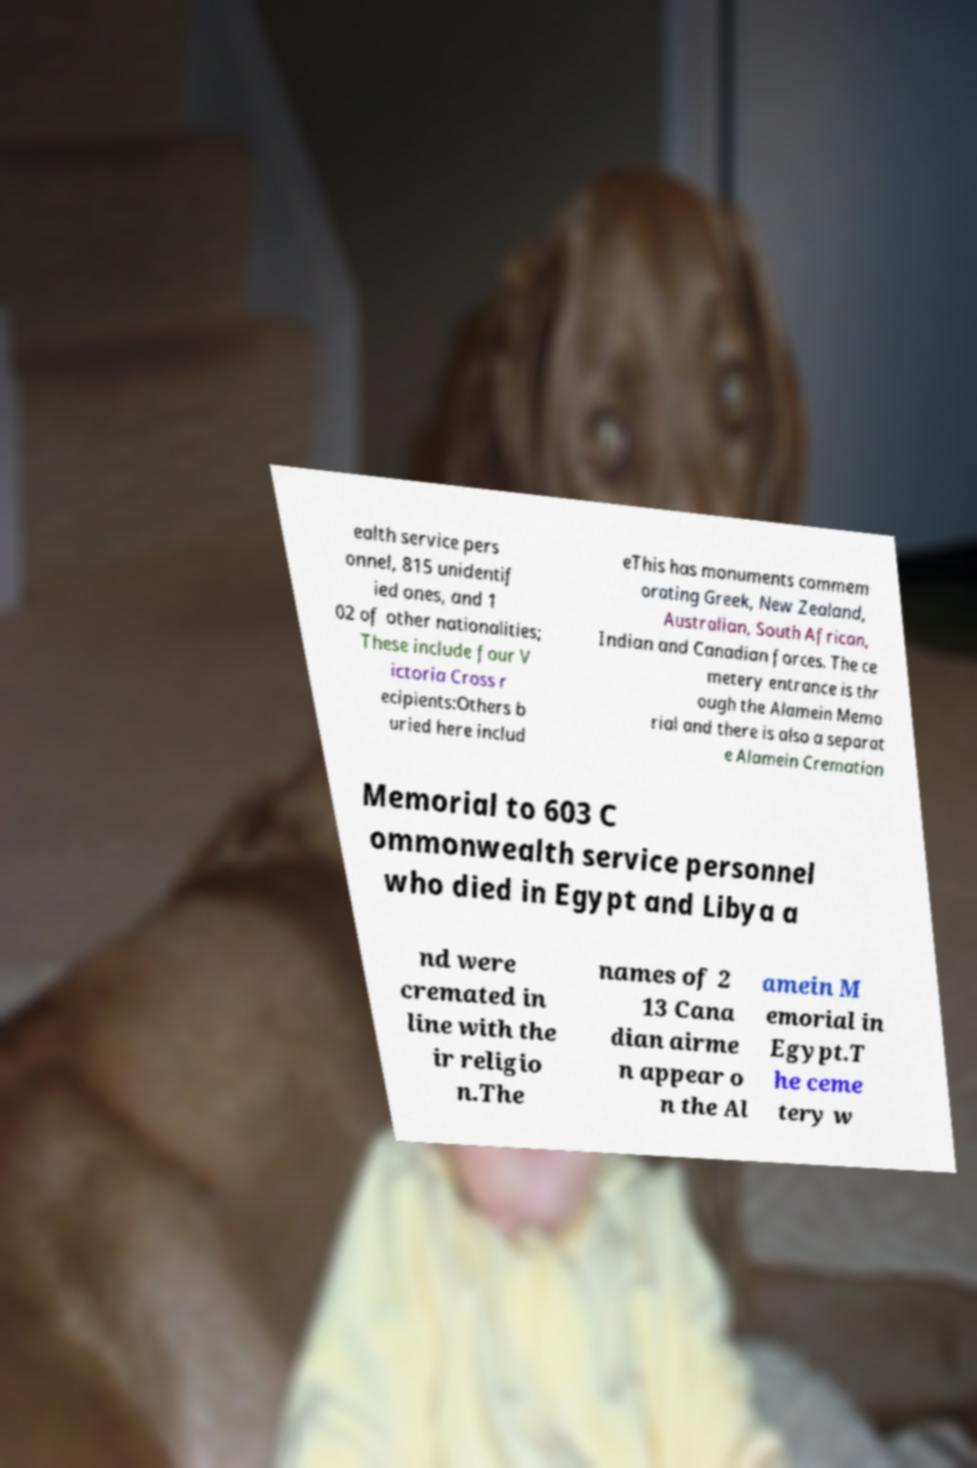There's text embedded in this image that I need extracted. Can you transcribe it verbatim? ealth service pers onnel, 815 unidentif ied ones, and 1 02 of other nationalities; These include four V ictoria Cross r ecipients:Others b uried here includ eThis has monuments commem orating Greek, New Zealand, Australian, South African, Indian and Canadian forces. The ce metery entrance is thr ough the Alamein Memo rial and there is also a separat e Alamein Cremation Memorial to 603 C ommonwealth service personnel who died in Egypt and Libya a nd were cremated in line with the ir religio n.The names of 2 13 Cana dian airme n appear o n the Al amein M emorial in Egypt.T he ceme tery w 